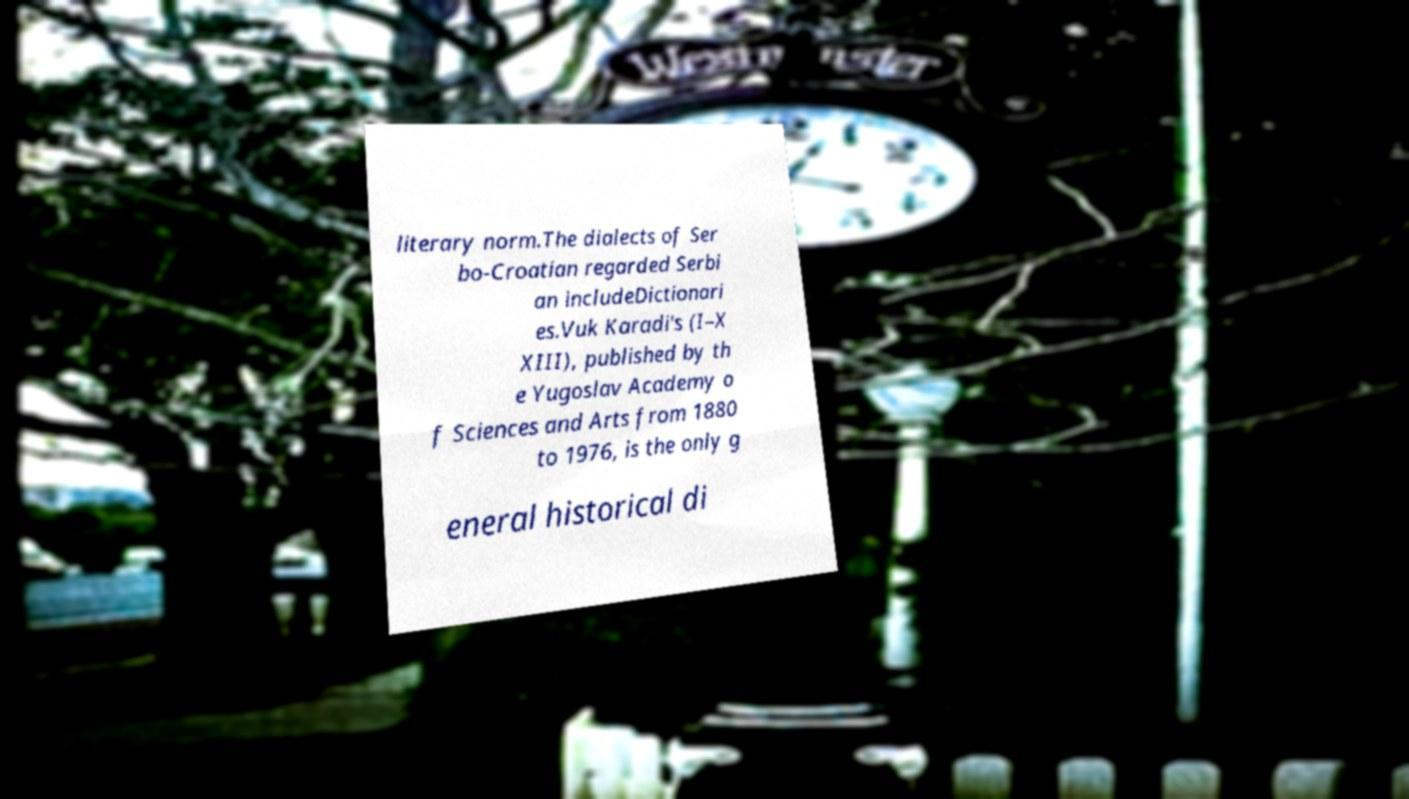For documentation purposes, I need the text within this image transcribed. Could you provide that? literary norm.The dialects of Ser bo-Croatian regarded Serbi an includeDictionari es.Vuk Karadi's (I–X XIII), published by th e Yugoslav Academy o f Sciences and Arts from 1880 to 1976, is the only g eneral historical di 